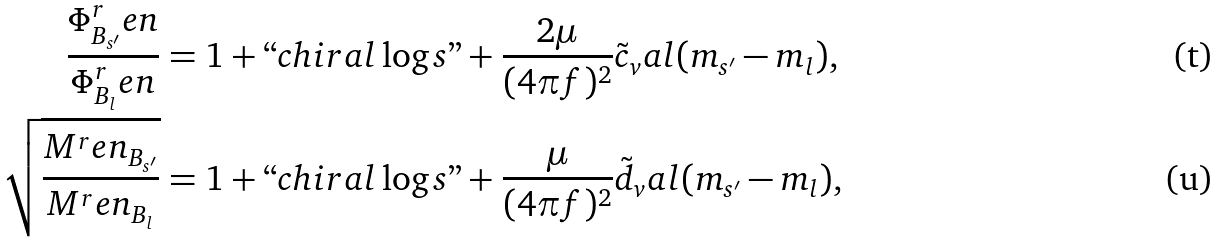Convert formula to latex. <formula><loc_0><loc_0><loc_500><loc_500>\frac { \Phi _ { B _ { s ^ { \prime } } } ^ { r } e n } { \Phi _ { B _ { l } } ^ { r } e n } & = 1 + ` ` c h i r a l \log s " + \frac { 2 \mu } { ( 4 \pi f ) ^ { 2 } } \tilde { c } _ { v } a l ( m _ { s ^ { \prime } } - m _ { l } ) , \\ \sqrt { \frac { M ^ { r } e n _ { B _ { s ^ { \prime } } } } { M ^ { r } e n _ { B _ { l } } } } & = 1 + ` ` c h i r a l \log s " + \frac { \mu } { ( 4 \pi f ) ^ { 2 } } \tilde { d } _ { v } a l ( m _ { s ^ { \prime } } - m _ { l } ) ,</formula> 